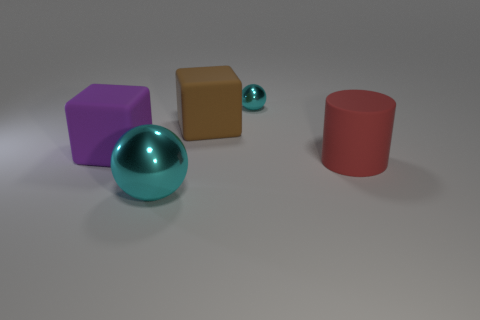Add 5 large cylinders. How many objects exist? 10 Subtract all cylinders. How many objects are left? 4 Add 1 big purple shiny cylinders. How many big purple shiny cylinders exist? 1 Subtract 0 purple spheres. How many objects are left? 5 Subtract all brown matte cubes. Subtract all big purple blocks. How many objects are left? 3 Add 1 brown objects. How many brown objects are left? 2 